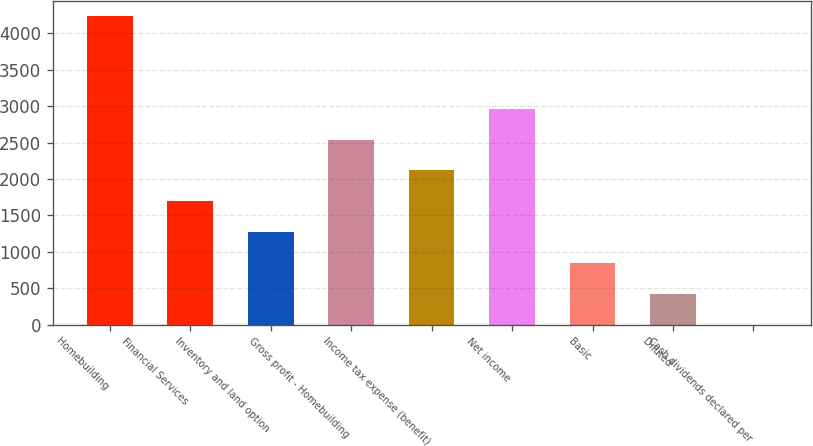Convert chart to OTSL. <chart><loc_0><loc_0><loc_500><loc_500><bar_chart><fcel>Homebuilding<fcel>Financial Services<fcel>Inventory and land option<fcel>Gross profit - Homebuilding<fcel>Income tax expense (benefit)<fcel>Net income<fcel>Basic<fcel>Diluted<fcel>Cash dividends declared per<nl><fcel>4236.2<fcel>1694.58<fcel>1270.97<fcel>2541.78<fcel>2118.18<fcel>2965.39<fcel>847.36<fcel>423.75<fcel>0.15<nl></chart> 